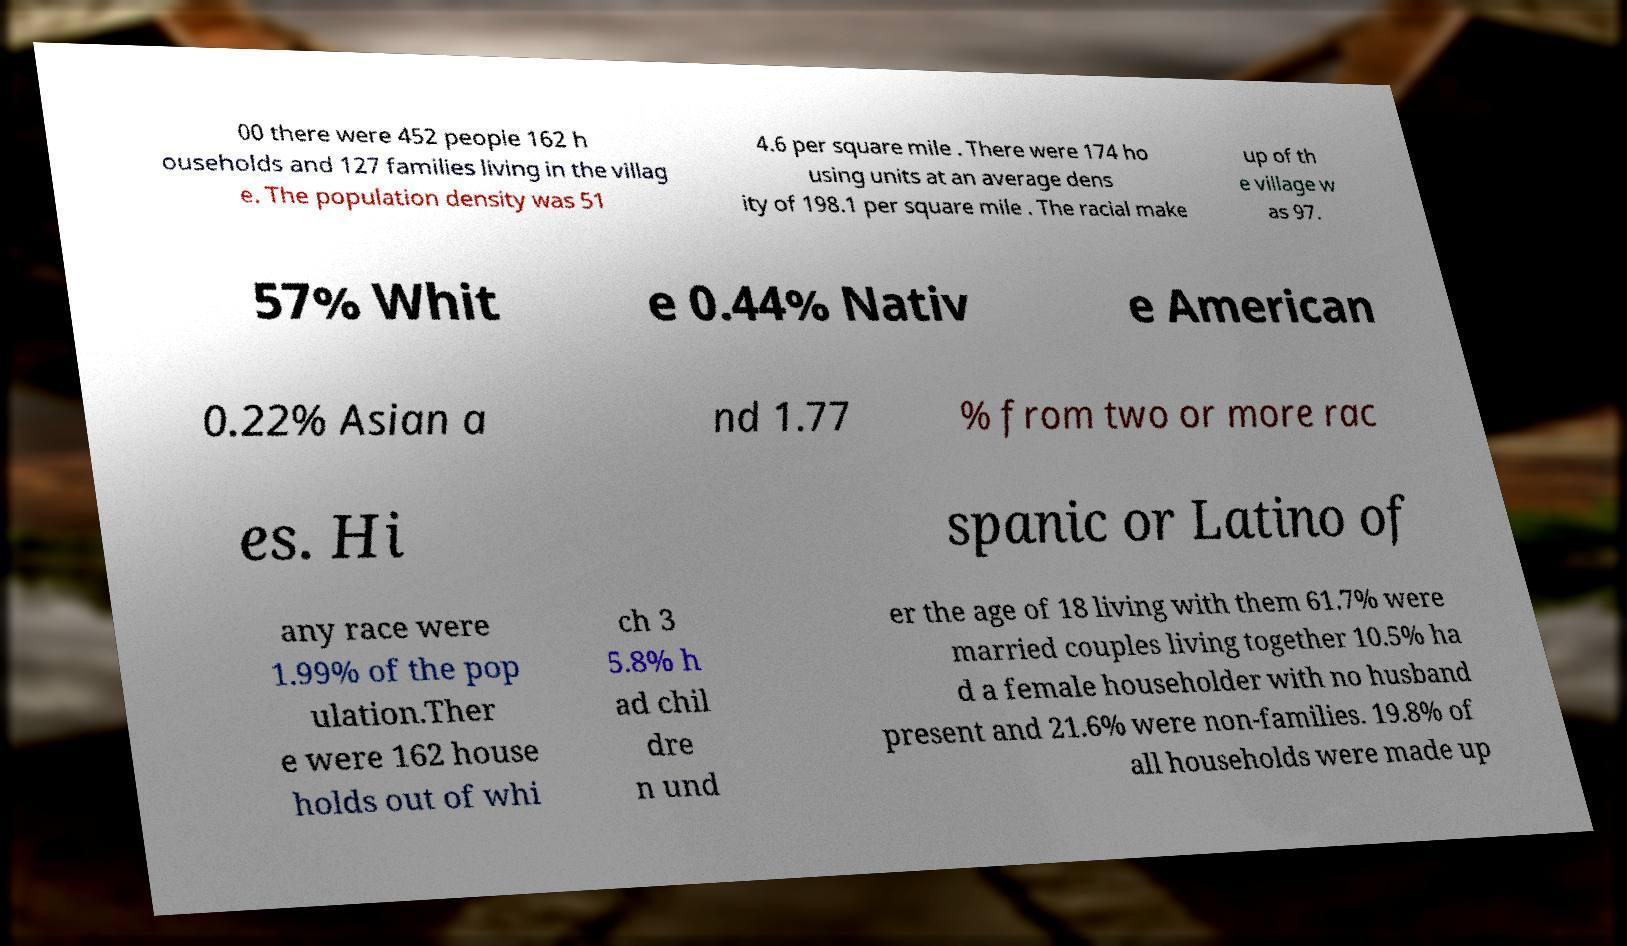Could you extract and type out the text from this image? 00 there were 452 people 162 h ouseholds and 127 families living in the villag e. The population density was 51 4.6 per square mile . There were 174 ho using units at an average dens ity of 198.1 per square mile . The racial make up of th e village w as 97. 57% Whit e 0.44% Nativ e American 0.22% Asian a nd 1.77 % from two or more rac es. Hi spanic or Latino of any race were 1.99% of the pop ulation.Ther e were 162 house holds out of whi ch 3 5.8% h ad chil dre n und er the age of 18 living with them 61.7% were married couples living together 10.5% ha d a female householder with no husband present and 21.6% were non-families. 19.8% of all households were made up 